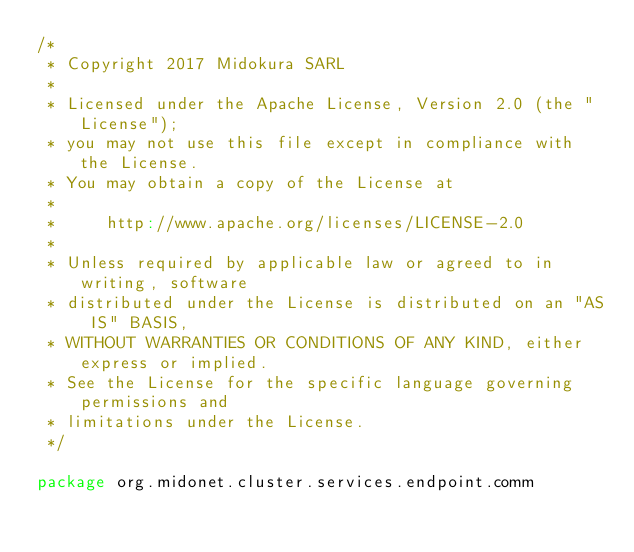<code> <loc_0><loc_0><loc_500><loc_500><_Scala_>/*
 * Copyright 2017 Midokura SARL
 *
 * Licensed under the Apache License, Version 2.0 (the "License");
 * you may not use this file except in compliance with the License.
 * You may obtain a copy of the License at
 *
 *     http://www.apache.org/licenses/LICENSE-2.0
 *
 * Unless required by applicable law or agreed to in writing, software
 * distributed under the License is distributed on an "AS IS" BASIS,
 * WITHOUT WARRANTIES OR CONDITIONS OF ANY KIND, either express or implied.
 * See the License for the specific language governing permissions and
 * limitations under the License.
 */

package org.midonet.cluster.services.endpoint.comm
</code> 